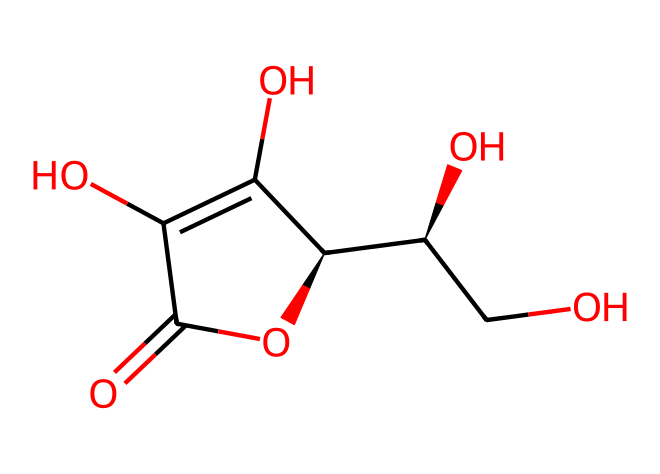What is the name of this compound? The SMILES representation provided corresponds to vitamin C, which is known for its role as an essential nutrient.
Answer: vitamin C How many carbon atoms are in the structure? By counting the carbon symbols (C) in the SMILES representation, we identify four carbon atoms in the main structure.
Answer: four What functional groups are present in this molecule? The structure contains hydroxyl (-OH) groups and a carbonyl (C=O) group, which are identifiable through the respective parts of the SMILES.
Answer: hydroxyl and carbonyl What is the molecular formula of vitamin C? From the structural interpretation of the SMILES, we can summarize the molecular composition as C6H8O6.
Answer: C6H8O6 How many hydroxyl groups are present in vitamin C? By analyzing the structure, we can see three hydroxyl (-OH) groups contributing to its properties.
Answer: three Why is vitamin C considered an important nutrient? Vitamin C is vital for the synthesis of collagen, among other functions, as implied by its structure which shows reactivity due to its functional groups.
Answer: collagen synthesis What type of compound is vitamin C? Vitamin C, based on its structure, is categorized as an aliphatic compound due to its lack of aromatic rings.
Answer: aliphatic 